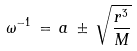Convert formula to latex. <formula><loc_0><loc_0><loc_500><loc_500>\omega ^ { - 1 } \, = \, a \, \pm \, \sqrt { \frac { r ^ { 3 } } { M } }</formula> 